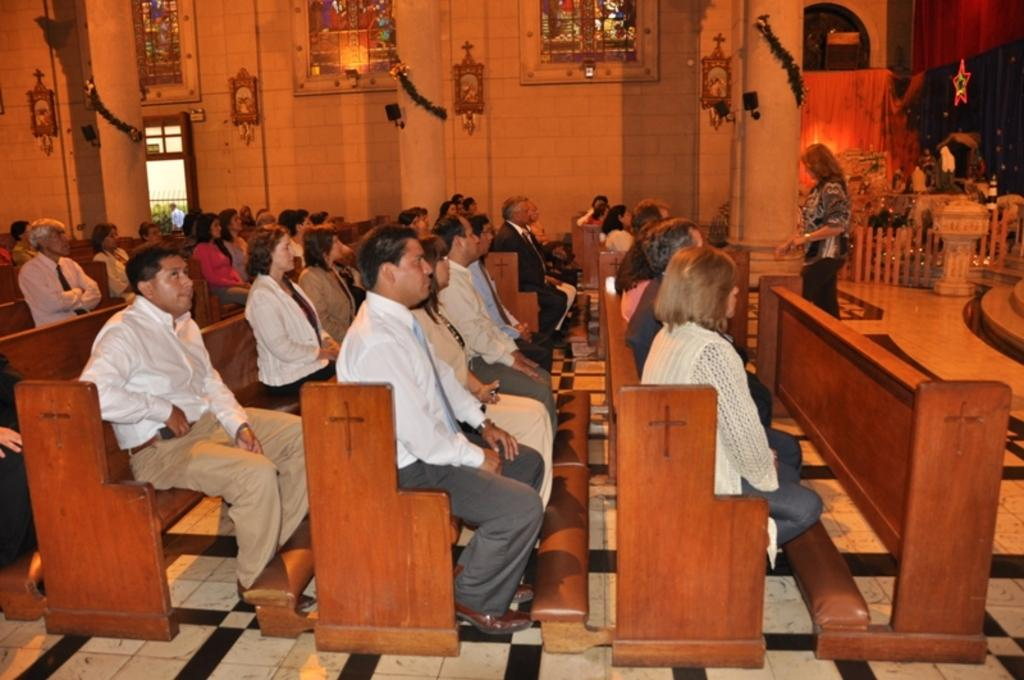Who is present in the image? There are people in the image. Where are the people located? The people are sitting in a church. What are the people doing in the church? The people are praying. How many icicles are hanging from the grandmother's foot in the image? There is no grandmother or icicles present in the image. 